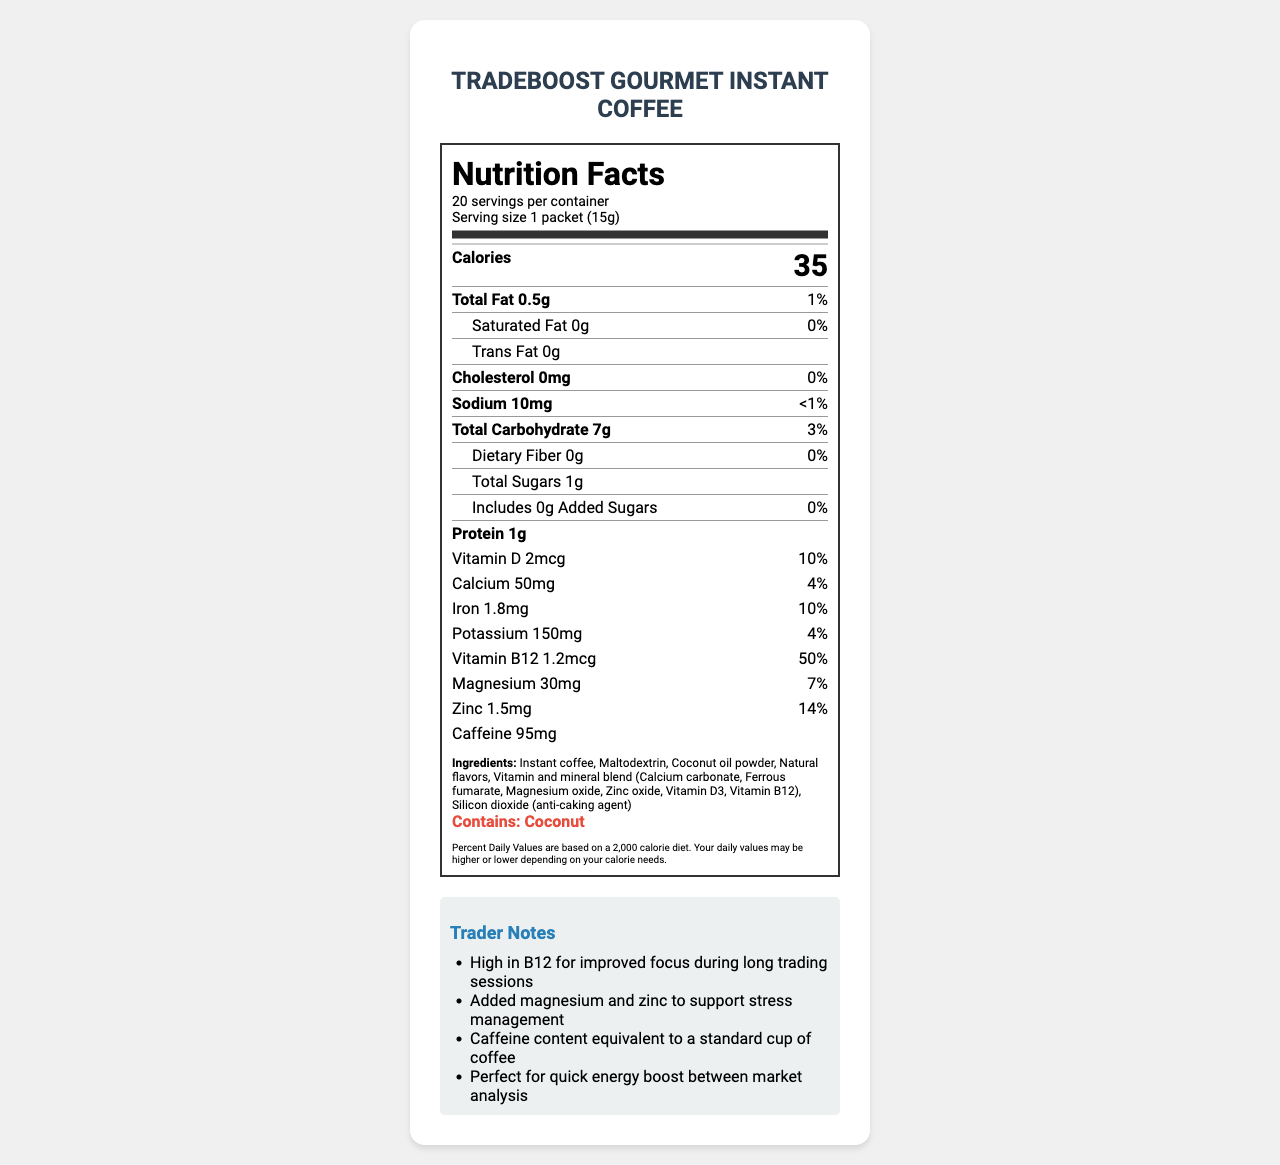how many packets are in one container? Referring to the document, it states there are 20 servings per container, and since the serving size is one packet, there are 20 packets in a container.
Answer: 20 what is the serving size? The serving size is clearly stated in the document as "1 packet (15g)."
Answer: 1 packet (15g) what percentage of daily value of vitamin B12 does one serving provide? The document lists that each serving provides 50% of the daily value for vitamin B12.
Answer: 50% how much caffeine is in one serving? The document states that one serving contains 95mg of caffeine.
Answer: 95mg is this product high in dietary fiber? The nutrition facts show the product has 0g of dietary fiber per serving, which implies it is not high in dietary fiber.
Answer: No how many vitamins and minerals are included in the formula? The document lists Vitamin D, Calcium, Iron, Potassium, Vitamin B12, Magnesium, and Zinc, which totals seven vitamins and minerals.
Answer: 7 what is the main purpose of the product, according to the trader notes? The Trader Notes section highlights that the product is meant for improved focus, quick energy boost, and stress management.
Answer: To provide energy and support focus during trading sessions does the product contain any allergens? The document indicates that it contains coconut, which is an allergen.
Answer: Yes what is the highest detectable nutrient in terms of daily value percentage? Vitamin B12 has the highest daily value percentage at 50%, compared to other nutrients listed.
Answer: Vitamin B12 how many calories are in one serving? The document states that each serving of the coffee contains 35 calories.
Answer: 35 which of the following nutrients is not included in the product? A. Omega-3 B. Vitamin D C. Magnesium D. Iron The document does not list Omega-3 as an included nutrient, whereas Vitamin D, Magnesium, and Iron are all mentioned.
Answer: A what is a possible benefit of the added magnesium listed in the trader notes? The trader notes indicate that magnesium is added to support stress management.
Answer: Stress management summarize the key nutritional features of the product. The product is described as having a specific nutritional profile including vitamins and minerals beneficial for traders seeking focus and energy boosts. The nutritional facts, ingredient list, and benefits are summarized based on the document.
Answer: TradeBoost Gourmet Instant Coffee is an instant coffee blend with added vitamins and minerals, designed for traders. It contains 35 calories per packet (15g), with significant amounts of Vitamin B12 (50% DV), Magnesium, and Zinc. The product has 0.5g total fat, 7g carbohydrates, 1g protein, and 95mg caffeine. It may improve focus and provide energy during long trading sessions. what flavors are listed in the ingredients? The ingredients list includes "Natural flavors," but does not specify what those flavors are. Therefore, the flavors cannot be determined from the document.
Answer: Not specified or identifiable 